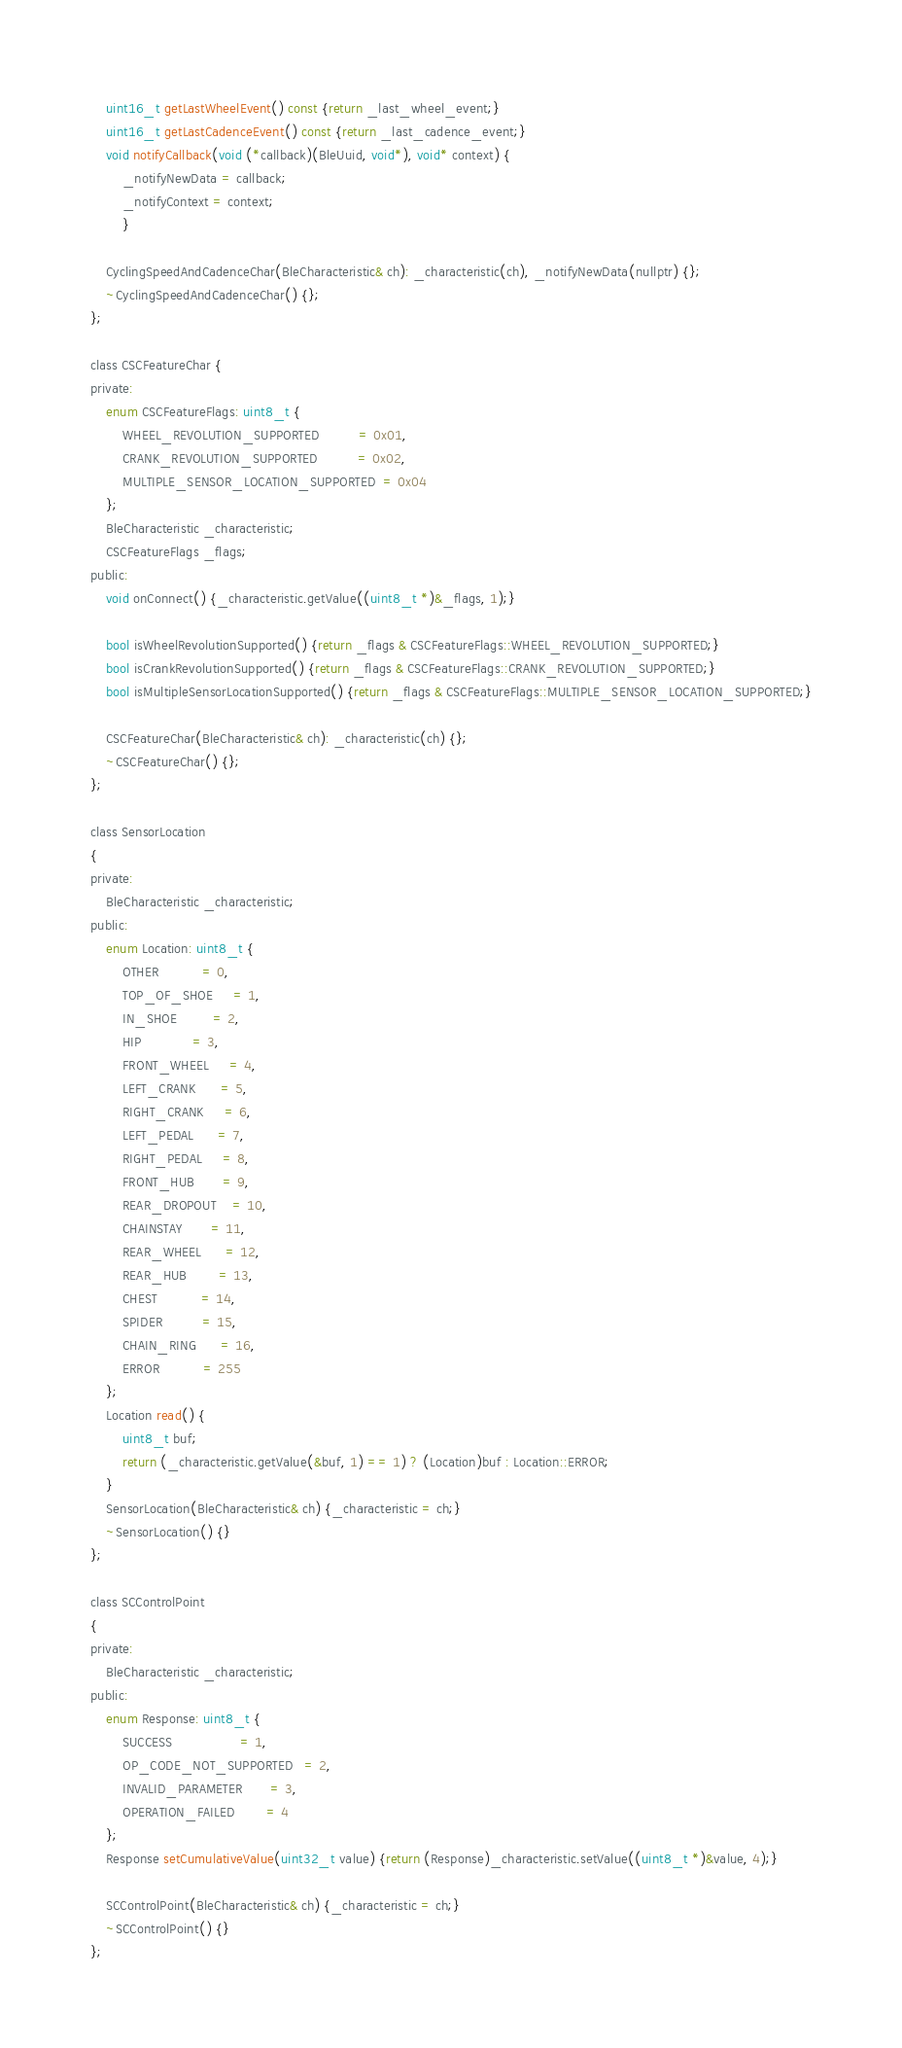Convert code to text. <code><loc_0><loc_0><loc_500><loc_500><_C_>    uint16_t getLastWheelEvent() const {return _last_wheel_event;}
    uint16_t getLastCadenceEvent() const {return _last_cadence_event;}
    void notifyCallback(void (*callback)(BleUuid, void*), void* context) {
        _notifyNewData = callback;
        _notifyContext = context;
        }
    
    CyclingSpeedAndCadenceChar(BleCharacteristic& ch): _characteristic(ch), _notifyNewData(nullptr) {};
    ~CyclingSpeedAndCadenceChar() {};
};

class CSCFeatureChar {
private:
    enum CSCFeatureFlags: uint8_t {
        WHEEL_REVOLUTION_SUPPORTED          = 0x01,
        CRANK_REVOLUTION_SUPPORTED          = 0x02,
        MULTIPLE_SENSOR_LOCATION_SUPPORTED  = 0x04
    };
    BleCharacteristic _characteristic;
    CSCFeatureFlags _flags;
public:
    void onConnect() {_characteristic.getValue((uint8_t *)&_flags, 1);}

    bool isWheelRevolutionSupported() {return _flags & CSCFeatureFlags::WHEEL_REVOLUTION_SUPPORTED;}
    bool isCrankRevolutionSupported() {return _flags & CSCFeatureFlags::CRANK_REVOLUTION_SUPPORTED;}
    bool isMultipleSensorLocationSupported() {return _flags & CSCFeatureFlags::MULTIPLE_SENSOR_LOCATION_SUPPORTED;}

    CSCFeatureChar(BleCharacteristic& ch): _characteristic(ch) {};
    ~CSCFeatureChar() {};
};

class SensorLocation 
{
private:
    BleCharacteristic _characteristic;
public:
    enum Location: uint8_t {
        OTHER           = 0,
        TOP_OF_SHOE     = 1,
        IN_SHOE         = 2,
        HIP             = 3,
        FRONT_WHEEL     = 4,
        LEFT_CRANK      = 5,
        RIGHT_CRANK     = 6,
        LEFT_PEDAL      = 7,
        RIGHT_PEDAL     = 8,
        FRONT_HUB       = 9,
        REAR_DROPOUT    = 10,
        CHAINSTAY       = 11,
        REAR_WHEEL      = 12,
        REAR_HUB        = 13,
        CHEST           = 14,
        SPIDER          = 15,
        CHAIN_RING      = 16,
        ERROR           = 255
    };
    Location read() {
        uint8_t buf;
        return (_characteristic.getValue(&buf, 1) == 1) ? (Location)buf : Location::ERROR; 
    }
    SensorLocation(BleCharacteristic& ch) {_characteristic = ch;}
    ~SensorLocation() {}
};

class SCControlPoint 
{
private:
    BleCharacteristic _characteristic;
public:
    enum Response: uint8_t {
        SUCCESS                 = 1,
        OP_CODE_NOT_SUPPORTED   = 2,
        INVALID_PARAMETER       = 3,
        OPERATION_FAILED        = 4
    };
    Response setCumulativeValue(uint32_t value) {return (Response)_characteristic.setValue((uint8_t *)&value, 4);}

    SCControlPoint(BleCharacteristic& ch) {_characteristic = ch;}
    ~SCControlPoint() {}
};</code> 